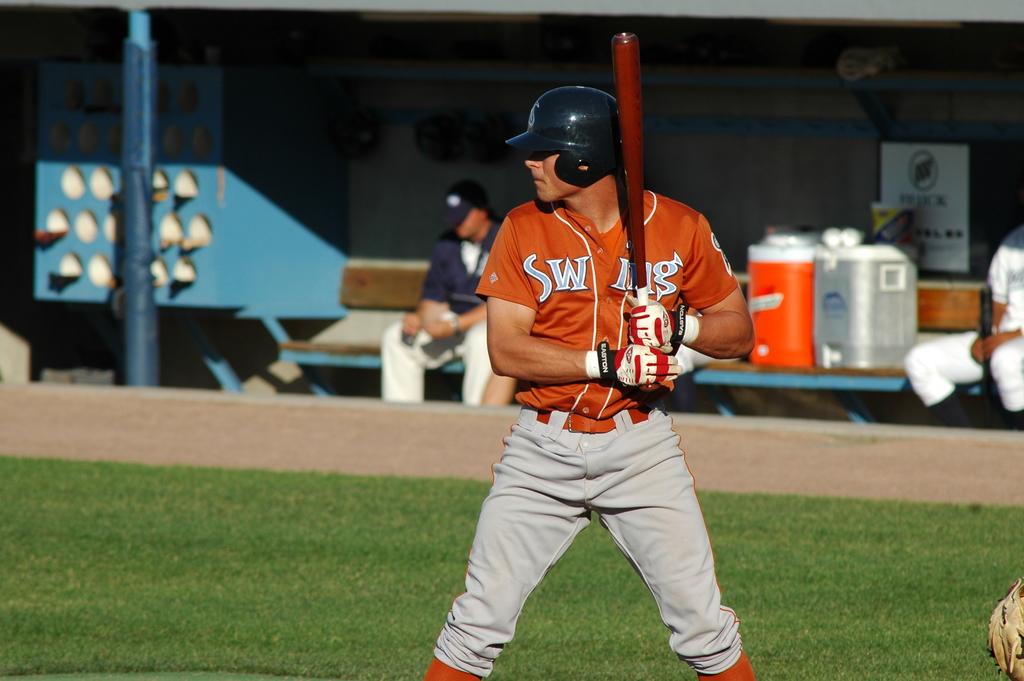What is this player's team name?
Provide a short and direct response. Swing. What type of game is this player playing?
Offer a very short reply. Baseball. 